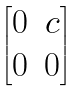<formula> <loc_0><loc_0><loc_500><loc_500>\begin{bmatrix} 0 & c \\ 0 & 0 \end{bmatrix}</formula> 